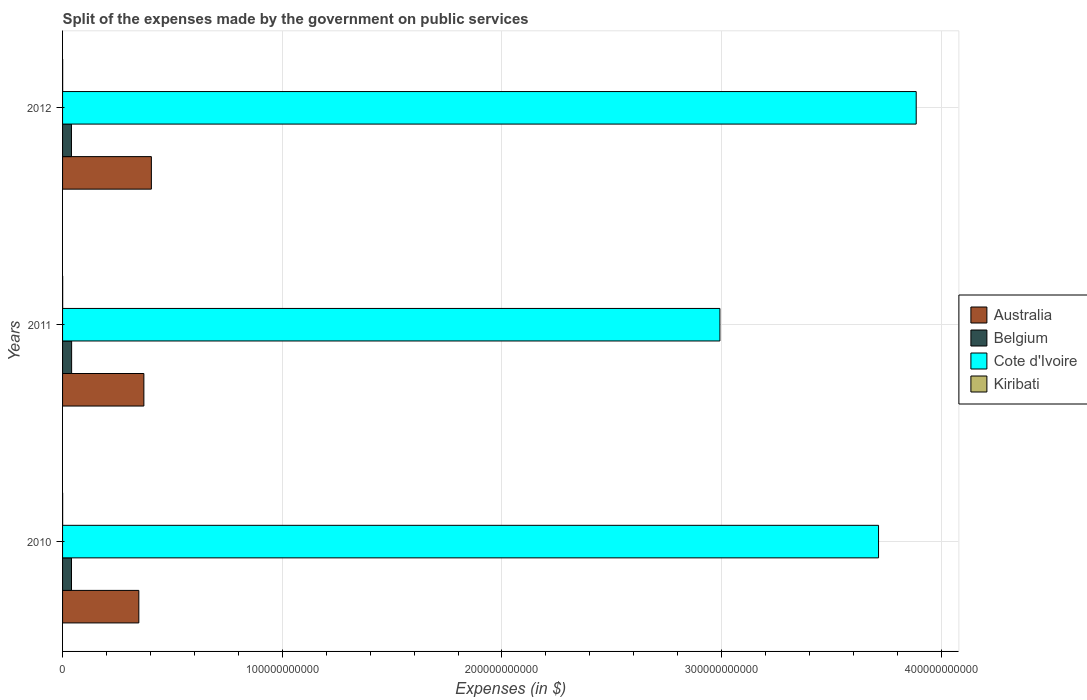Are the number of bars on each tick of the Y-axis equal?
Your answer should be compact. Yes. What is the label of the 3rd group of bars from the top?
Make the answer very short. 2010. What is the expenses made by the government on public services in Cote d'Ivoire in 2011?
Make the answer very short. 2.99e+11. Across all years, what is the maximum expenses made by the government on public services in Cote d'Ivoire?
Ensure brevity in your answer.  3.89e+11. Across all years, what is the minimum expenses made by the government on public services in Belgium?
Ensure brevity in your answer.  4.05e+09. In which year was the expenses made by the government on public services in Belgium maximum?
Offer a terse response. 2011. In which year was the expenses made by the government on public services in Belgium minimum?
Ensure brevity in your answer.  2012. What is the total expenses made by the government on public services in Kiribati in the graph?
Offer a very short reply. 1.26e+08. What is the difference between the expenses made by the government on public services in Cote d'Ivoire in 2011 and that in 2012?
Offer a very short reply. -8.94e+1. What is the difference between the expenses made by the government on public services in Belgium in 2010 and the expenses made by the government on public services in Australia in 2012?
Your answer should be compact. -3.64e+1. What is the average expenses made by the government on public services in Cote d'Ivoire per year?
Provide a succinct answer. 3.53e+11. In the year 2012, what is the difference between the expenses made by the government on public services in Belgium and expenses made by the government on public services in Australia?
Your answer should be compact. -3.64e+1. What is the ratio of the expenses made by the government on public services in Cote d'Ivoire in 2010 to that in 2011?
Your answer should be compact. 1.24. Is the expenses made by the government on public services in Australia in 2010 less than that in 2011?
Provide a succinct answer. Yes. What is the difference between the highest and the second highest expenses made by the government on public services in Belgium?
Give a very brief answer. 5.37e+07. What is the difference between the highest and the lowest expenses made by the government on public services in Belgium?
Give a very brief answer. 7.23e+07. Is it the case that in every year, the sum of the expenses made by the government on public services in Kiribati and expenses made by the government on public services in Belgium is greater than the sum of expenses made by the government on public services in Australia and expenses made by the government on public services in Cote d'Ivoire?
Offer a terse response. No. Is it the case that in every year, the sum of the expenses made by the government on public services in Cote d'Ivoire and expenses made by the government on public services in Australia is greater than the expenses made by the government on public services in Belgium?
Offer a very short reply. Yes. Are all the bars in the graph horizontal?
Make the answer very short. Yes. What is the difference between two consecutive major ticks on the X-axis?
Provide a short and direct response. 1.00e+11. Does the graph contain any zero values?
Offer a terse response. No. Where does the legend appear in the graph?
Provide a succinct answer. Center right. What is the title of the graph?
Your answer should be compact. Split of the expenses made by the government on public services. Does "Togo" appear as one of the legend labels in the graph?
Provide a succinct answer. No. What is the label or title of the X-axis?
Make the answer very short. Expenses (in $). What is the Expenses (in $) in Australia in 2010?
Your answer should be compact. 3.47e+1. What is the Expenses (in $) of Belgium in 2010?
Ensure brevity in your answer.  4.07e+09. What is the Expenses (in $) of Cote d'Ivoire in 2010?
Your answer should be very brief. 3.71e+11. What is the Expenses (in $) in Kiribati in 2010?
Offer a very short reply. 3.66e+07. What is the Expenses (in $) of Australia in 2011?
Keep it short and to the point. 3.70e+1. What is the Expenses (in $) in Belgium in 2011?
Provide a succinct answer. 4.12e+09. What is the Expenses (in $) in Cote d'Ivoire in 2011?
Make the answer very short. 2.99e+11. What is the Expenses (in $) in Kiribati in 2011?
Your answer should be very brief. 4.81e+07. What is the Expenses (in $) of Australia in 2012?
Ensure brevity in your answer.  4.04e+1. What is the Expenses (in $) in Belgium in 2012?
Give a very brief answer. 4.05e+09. What is the Expenses (in $) of Cote d'Ivoire in 2012?
Make the answer very short. 3.89e+11. What is the Expenses (in $) of Kiribati in 2012?
Provide a short and direct response. 4.09e+07. Across all years, what is the maximum Expenses (in $) of Australia?
Your response must be concise. 4.04e+1. Across all years, what is the maximum Expenses (in $) of Belgium?
Keep it short and to the point. 4.12e+09. Across all years, what is the maximum Expenses (in $) of Cote d'Ivoire?
Your response must be concise. 3.89e+11. Across all years, what is the maximum Expenses (in $) of Kiribati?
Give a very brief answer. 4.81e+07. Across all years, what is the minimum Expenses (in $) in Australia?
Keep it short and to the point. 3.47e+1. Across all years, what is the minimum Expenses (in $) in Belgium?
Offer a very short reply. 4.05e+09. Across all years, what is the minimum Expenses (in $) in Cote d'Ivoire?
Offer a terse response. 2.99e+11. Across all years, what is the minimum Expenses (in $) of Kiribati?
Offer a very short reply. 3.66e+07. What is the total Expenses (in $) of Australia in the graph?
Make the answer very short. 1.12e+11. What is the total Expenses (in $) of Belgium in the graph?
Provide a short and direct response. 1.22e+1. What is the total Expenses (in $) of Cote d'Ivoire in the graph?
Make the answer very short. 1.06e+12. What is the total Expenses (in $) of Kiribati in the graph?
Offer a terse response. 1.26e+08. What is the difference between the Expenses (in $) in Australia in 2010 and that in 2011?
Offer a very short reply. -2.30e+09. What is the difference between the Expenses (in $) of Belgium in 2010 and that in 2011?
Provide a short and direct response. -5.37e+07. What is the difference between the Expenses (in $) of Cote d'Ivoire in 2010 and that in 2011?
Provide a short and direct response. 7.22e+1. What is the difference between the Expenses (in $) in Kiribati in 2010 and that in 2011?
Provide a succinct answer. -1.16e+07. What is the difference between the Expenses (in $) in Australia in 2010 and that in 2012?
Make the answer very short. -5.70e+09. What is the difference between the Expenses (in $) in Belgium in 2010 and that in 2012?
Provide a short and direct response. 1.86e+07. What is the difference between the Expenses (in $) in Cote d'Ivoire in 2010 and that in 2012?
Ensure brevity in your answer.  -1.71e+1. What is the difference between the Expenses (in $) in Kiribati in 2010 and that in 2012?
Provide a succinct answer. -4.32e+06. What is the difference between the Expenses (in $) of Australia in 2011 and that in 2012?
Give a very brief answer. -3.41e+09. What is the difference between the Expenses (in $) of Belgium in 2011 and that in 2012?
Offer a very short reply. 7.23e+07. What is the difference between the Expenses (in $) in Cote d'Ivoire in 2011 and that in 2012?
Provide a succinct answer. -8.94e+1. What is the difference between the Expenses (in $) in Kiribati in 2011 and that in 2012?
Ensure brevity in your answer.  7.24e+06. What is the difference between the Expenses (in $) in Australia in 2010 and the Expenses (in $) in Belgium in 2011?
Make the answer very short. 3.06e+1. What is the difference between the Expenses (in $) of Australia in 2010 and the Expenses (in $) of Cote d'Ivoire in 2011?
Offer a very short reply. -2.65e+11. What is the difference between the Expenses (in $) of Australia in 2010 and the Expenses (in $) of Kiribati in 2011?
Ensure brevity in your answer.  3.47e+1. What is the difference between the Expenses (in $) in Belgium in 2010 and the Expenses (in $) in Cote d'Ivoire in 2011?
Your answer should be compact. -2.95e+11. What is the difference between the Expenses (in $) of Belgium in 2010 and the Expenses (in $) of Kiribati in 2011?
Offer a terse response. 4.02e+09. What is the difference between the Expenses (in $) of Cote d'Ivoire in 2010 and the Expenses (in $) of Kiribati in 2011?
Your answer should be compact. 3.71e+11. What is the difference between the Expenses (in $) of Australia in 2010 and the Expenses (in $) of Belgium in 2012?
Offer a terse response. 3.07e+1. What is the difference between the Expenses (in $) in Australia in 2010 and the Expenses (in $) in Cote d'Ivoire in 2012?
Provide a succinct answer. -3.54e+11. What is the difference between the Expenses (in $) in Australia in 2010 and the Expenses (in $) in Kiribati in 2012?
Your answer should be very brief. 3.47e+1. What is the difference between the Expenses (in $) of Belgium in 2010 and the Expenses (in $) of Cote d'Ivoire in 2012?
Your response must be concise. -3.85e+11. What is the difference between the Expenses (in $) in Belgium in 2010 and the Expenses (in $) in Kiribati in 2012?
Provide a short and direct response. 4.03e+09. What is the difference between the Expenses (in $) of Cote d'Ivoire in 2010 and the Expenses (in $) of Kiribati in 2012?
Make the answer very short. 3.71e+11. What is the difference between the Expenses (in $) of Australia in 2011 and the Expenses (in $) of Belgium in 2012?
Provide a succinct answer. 3.30e+1. What is the difference between the Expenses (in $) of Australia in 2011 and the Expenses (in $) of Cote d'Ivoire in 2012?
Ensure brevity in your answer.  -3.52e+11. What is the difference between the Expenses (in $) in Australia in 2011 and the Expenses (in $) in Kiribati in 2012?
Provide a succinct answer. 3.70e+1. What is the difference between the Expenses (in $) of Belgium in 2011 and the Expenses (in $) of Cote d'Ivoire in 2012?
Make the answer very short. -3.84e+11. What is the difference between the Expenses (in $) of Belgium in 2011 and the Expenses (in $) of Kiribati in 2012?
Your response must be concise. 4.08e+09. What is the difference between the Expenses (in $) of Cote d'Ivoire in 2011 and the Expenses (in $) of Kiribati in 2012?
Provide a short and direct response. 2.99e+11. What is the average Expenses (in $) of Australia per year?
Ensure brevity in your answer.  3.74e+1. What is the average Expenses (in $) in Belgium per year?
Ensure brevity in your answer.  4.08e+09. What is the average Expenses (in $) of Cote d'Ivoire per year?
Your answer should be compact. 3.53e+11. What is the average Expenses (in $) of Kiribati per year?
Give a very brief answer. 4.19e+07. In the year 2010, what is the difference between the Expenses (in $) in Australia and Expenses (in $) in Belgium?
Provide a succinct answer. 3.06e+1. In the year 2010, what is the difference between the Expenses (in $) of Australia and Expenses (in $) of Cote d'Ivoire?
Keep it short and to the point. -3.37e+11. In the year 2010, what is the difference between the Expenses (in $) in Australia and Expenses (in $) in Kiribati?
Your answer should be very brief. 3.47e+1. In the year 2010, what is the difference between the Expenses (in $) of Belgium and Expenses (in $) of Cote d'Ivoire?
Give a very brief answer. -3.67e+11. In the year 2010, what is the difference between the Expenses (in $) in Belgium and Expenses (in $) in Kiribati?
Your answer should be very brief. 4.03e+09. In the year 2010, what is the difference between the Expenses (in $) in Cote d'Ivoire and Expenses (in $) in Kiribati?
Provide a succinct answer. 3.71e+11. In the year 2011, what is the difference between the Expenses (in $) in Australia and Expenses (in $) in Belgium?
Offer a very short reply. 3.29e+1. In the year 2011, what is the difference between the Expenses (in $) in Australia and Expenses (in $) in Cote d'Ivoire?
Your response must be concise. -2.62e+11. In the year 2011, what is the difference between the Expenses (in $) of Australia and Expenses (in $) of Kiribati?
Provide a succinct answer. 3.70e+1. In the year 2011, what is the difference between the Expenses (in $) of Belgium and Expenses (in $) of Cote d'Ivoire?
Keep it short and to the point. -2.95e+11. In the year 2011, what is the difference between the Expenses (in $) in Belgium and Expenses (in $) in Kiribati?
Provide a succinct answer. 4.07e+09. In the year 2011, what is the difference between the Expenses (in $) of Cote d'Ivoire and Expenses (in $) of Kiribati?
Ensure brevity in your answer.  2.99e+11. In the year 2012, what is the difference between the Expenses (in $) of Australia and Expenses (in $) of Belgium?
Offer a very short reply. 3.64e+1. In the year 2012, what is the difference between the Expenses (in $) of Australia and Expenses (in $) of Cote d'Ivoire?
Give a very brief answer. -3.48e+11. In the year 2012, what is the difference between the Expenses (in $) in Australia and Expenses (in $) in Kiribati?
Your answer should be compact. 4.04e+1. In the year 2012, what is the difference between the Expenses (in $) of Belgium and Expenses (in $) of Cote d'Ivoire?
Offer a very short reply. -3.85e+11. In the year 2012, what is the difference between the Expenses (in $) of Belgium and Expenses (in $) of Kiribati?
Ensure brevity in your answer.  4.01e+09. In the year 2012, what is the difference between the Expenses (in $) of Cote d'Ivoire and Expenses (in $) of Kiribati?
Make the answer very short. 3.89e+11. What is the ratio of the Expenses (in $) of Australia in 2010 to that in 2011?
Ensure brevity in your answer.  0.94. What is the ratio of the Expenses (in $) in Belgium in 2010 to that in 2011?
Provide a succinct answer. 0.99. What is the ratio of the Expenses (in $) of Cote d'Ivoire in 2010 to that in 2011?
Offer a terse response. 1.24. What is the ratio of the Expenses (in $) in Kiribati in 2010 to that in 2011?
Provide a short and direct response. 0.76. What is the ratio of the Expenses (in $) in Australia in 2010 to that in 2012?
Your answer should be compact. 0.86. What is the ratio of the Expenses (in $) of Cote d'Ivoire in 2010 to that in 2012?
Your answer should be very brief. 0.96. What is the ratio of the Expenses (in $) of Kiribati in 2010 to that in 2012?
Ensure brevity in your answer.  0.89. What is the ratio of the Expenses (in $) in Australia in 2011 to that in 2012?
Keep it short and to the point. 0.92. What is the ratio of the Expenses (in $) of Belgium in 2011 to that in 2012?
Your response must be concise. 1.02. What is the ratio of the Expenses (in $) of Cote d'Ivoire in 2011 to that in 2012?
Provide a succinct answer. 0.77. What is the ratio of the Expenses (in $) of Kiribati in 2011 to that in 2012?
Your answer should be compact. 1.18. What is the difference between the highest and the second highest Expenses (in $) of Australia?
Your answer should be very brief. 3.41e+09. What is the difference between the highest and the second highest Expenses (in $) of Belgium?
Provide a succinct answer. 5.37e+07. What is the difference between the highest and the second highest Expenses (in $) of Cote d'Ivoire?
Give a very brief answer. 1.71e+1. What is the difference between the highest and the second highest Expenses (in $) in Kiribati?
Provide a succinct answer. 7.24e+06. What is the difference between the highest and the lowest Expenses (in $) of Australia?
Your response must be concise. 5.70e+09. What is the difference between the highest and the lowest Expenses (in $) in Belgium?
Keep it short and to the point. 7.23e+07. What is the difference between the highest and the lowest Expenses (in $) in Cote d'Ivoire?
Keep it short and to the point. 8.94e+1. What is the difference between the highest and the lowest Expenses (in $) in Kiribati?
Your answer should be very brief. 1.16e+07. 